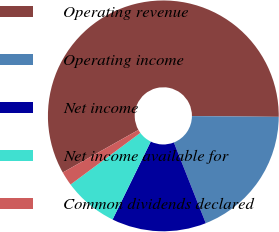Convert chart. <chart><loc_0><loc_0><loc_500><loc_500><pie_chart><fcel>Operating revenue<fcel>Operating income<fcel>Net income<fcel>Net income available for<fcel>Common dividends declared<nl><fcel>58.29%<fcel>18.87%<fcel>13.24%<fcel>7.61%<fcel>1.98%<nl></chart> 